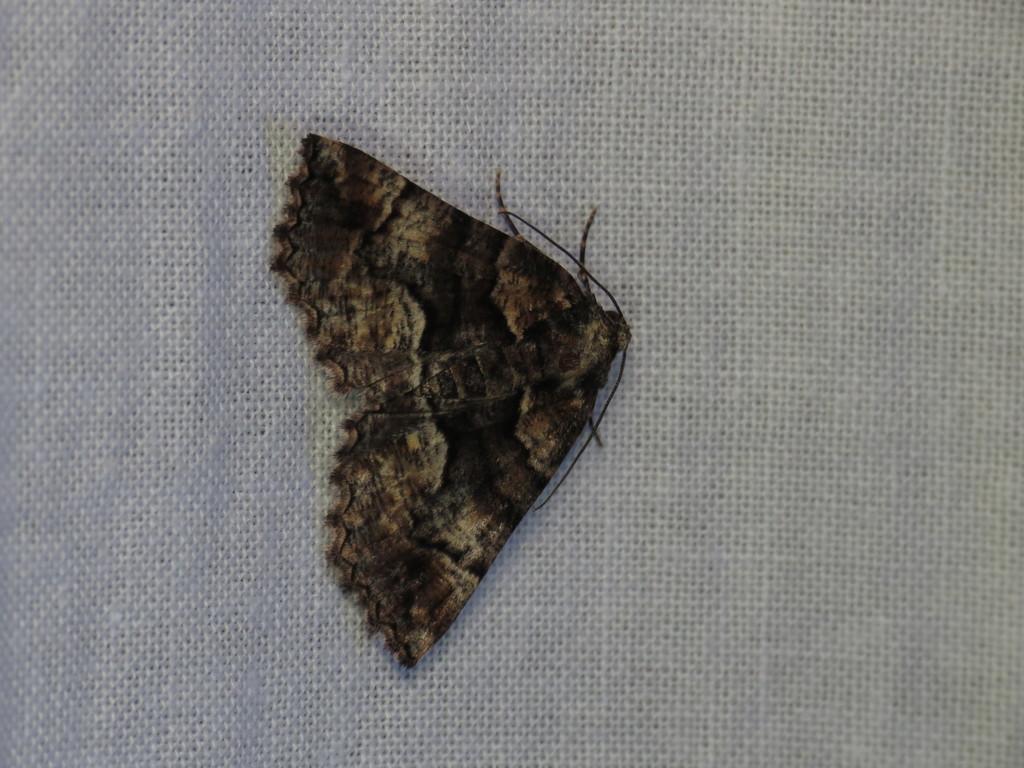Please provide a concise description of this image. In this picture, we see an insect which looks like a butterfly is in black color. In the background, it is white in color. 